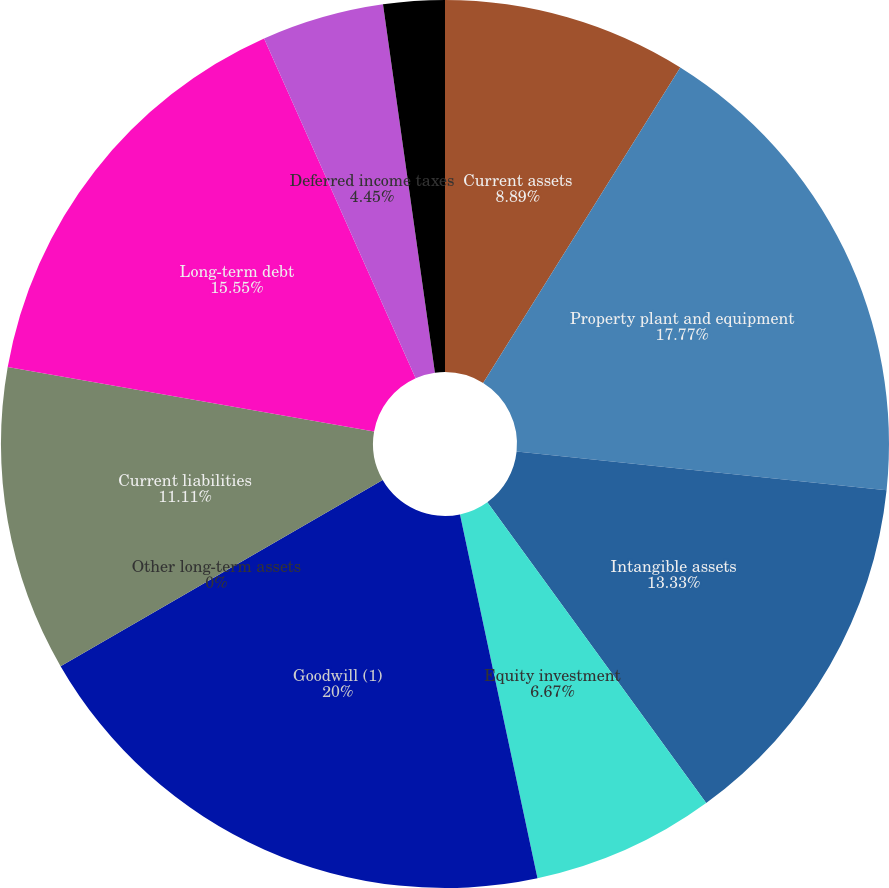Convert chart. <chart><loc_0><loc_0><loc_500><loc_500><pie_chart><fcel>Current assets<fcel>Property plant and equipment<fcel>Intangible assets<fcel>Equity investment<fcel>Goodwill (1)<fcel>Other long-term assets<fcel>Current liabilities<fcel>Long-term debt<fcel>Deferred income taxes<fcel>Other long-term liabilities<nl><fcel>8.89%<fcel>17.77%<fcel>13.33%<fcel>6.67%<fcel>20.0%<fcel>0.0%<fcel>11.11%<fcel>15.55%<fcel>4.45%<fcel>2.23%<nl></chart> 